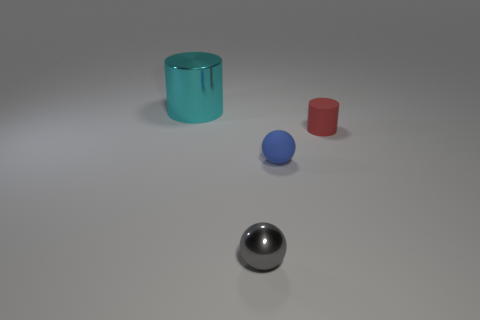Is there anything else that is the same size as the cyan object?
Make the answer very short. No. The large object has what color?
Keep it short and to the point. Cyan. What number of big cyan things have the same shape as the tiny red rubber thing?
Keep it short and to the point. 1. Is the cylinder that is to the right of the large cyan metal cylinder made of the same material as the blue sphere that is to the right of the tiny shiny ball?
Your response must be concise. Yes. What size is the metal thing that is behind the shiny object that is to the right of the large cyan thing?
Your answer should be compact. Large. There is another thing that is the same shape as the large cyan shiny object; what is it made of?
Keep it short and to the point. Rubber. There is a matte object that is behind the blue matte object; is its shape the same as the shiny object behind the gray metal sphere?
Provide a short and direct response. Yes. Are there more small matte cylinders than large brown metal cylinders?
Offer a terse response. Yes. The cyan metallic thing is what size?
Provide a short and direct response. Large. Is the cylinder to the left of the rubber cylinder made of the same material as the small red object?
Keep it short and to the point. No. 